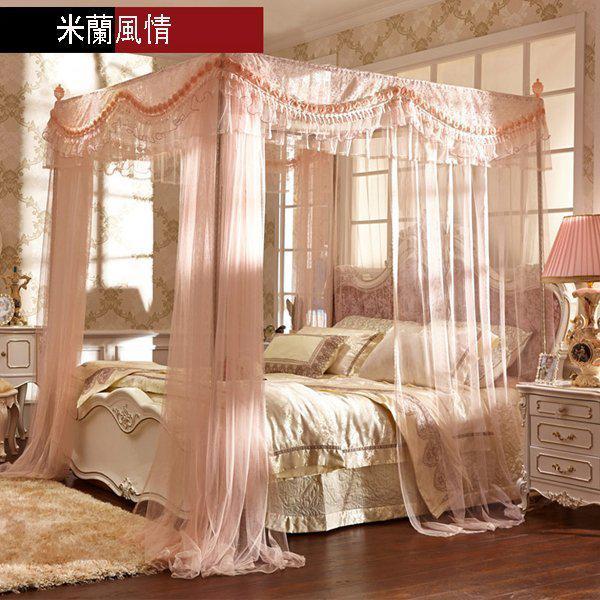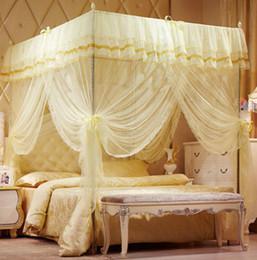The first image is the image on the left, the second image is the image on the right. Assess this claim about the two images: "Both images show beds with the same shape of overhead drapery, but differing in construction detailing and in color.". Correct or not? Answer yes or no. Yes. 